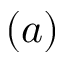Convert formula to latex. <formula><loc_0><loc_0><loc_500><loc_500>( a )</formula> 